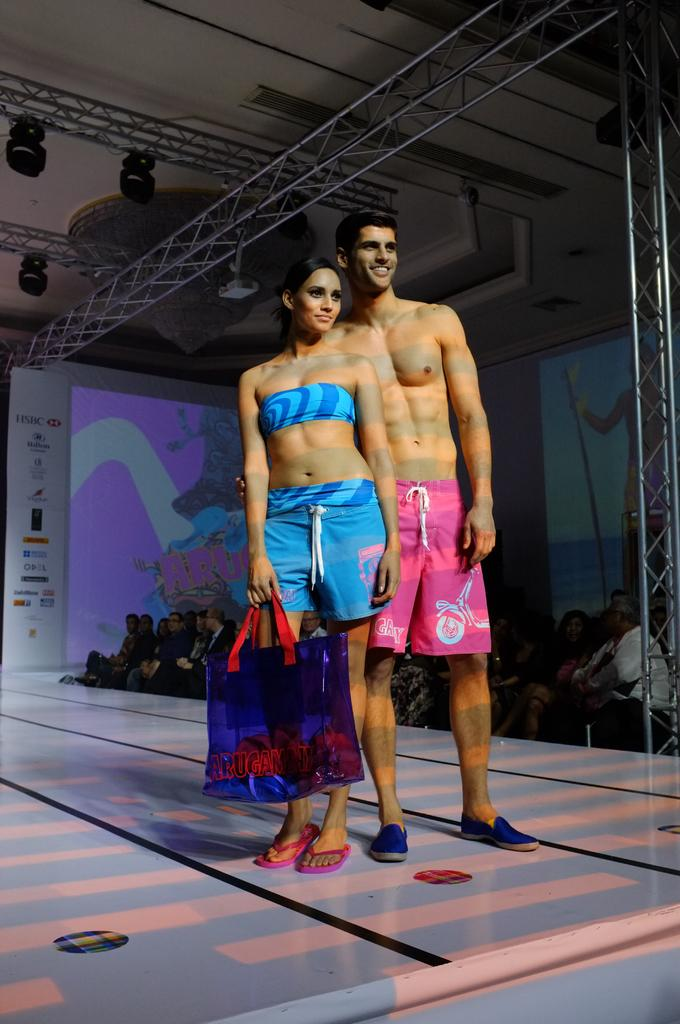What is happening on the stage in the image? There are two people standing on a stage in the image. Can you describe one of the people on the stage? One of the people on the stage is a woman. What is the woman holding in the image? The woman is holding a bag. What can be seen in the background of the stage? There is a hoarding visible in the background. What type of lighting is present on the stage? Focusing lights are present on the stage. What are the rods used for in the image? The rods are likely used for stage props or set design. What are the screens used for in the image? The screens might be used for displaying visuals or information during the event. What type of decorative lighting is visible in the image? A chandelier is visible in the image. Who is present in the audience in the image? There is an audience in the image, but their specific identities cannot be determined. What type of trucks can be seen in the image? There are no trucks present in the image. What time of day is it in the image, considering it's an afternoon event? The time of day cannot be determined from the image, and there is no mention of an afternoon event. 